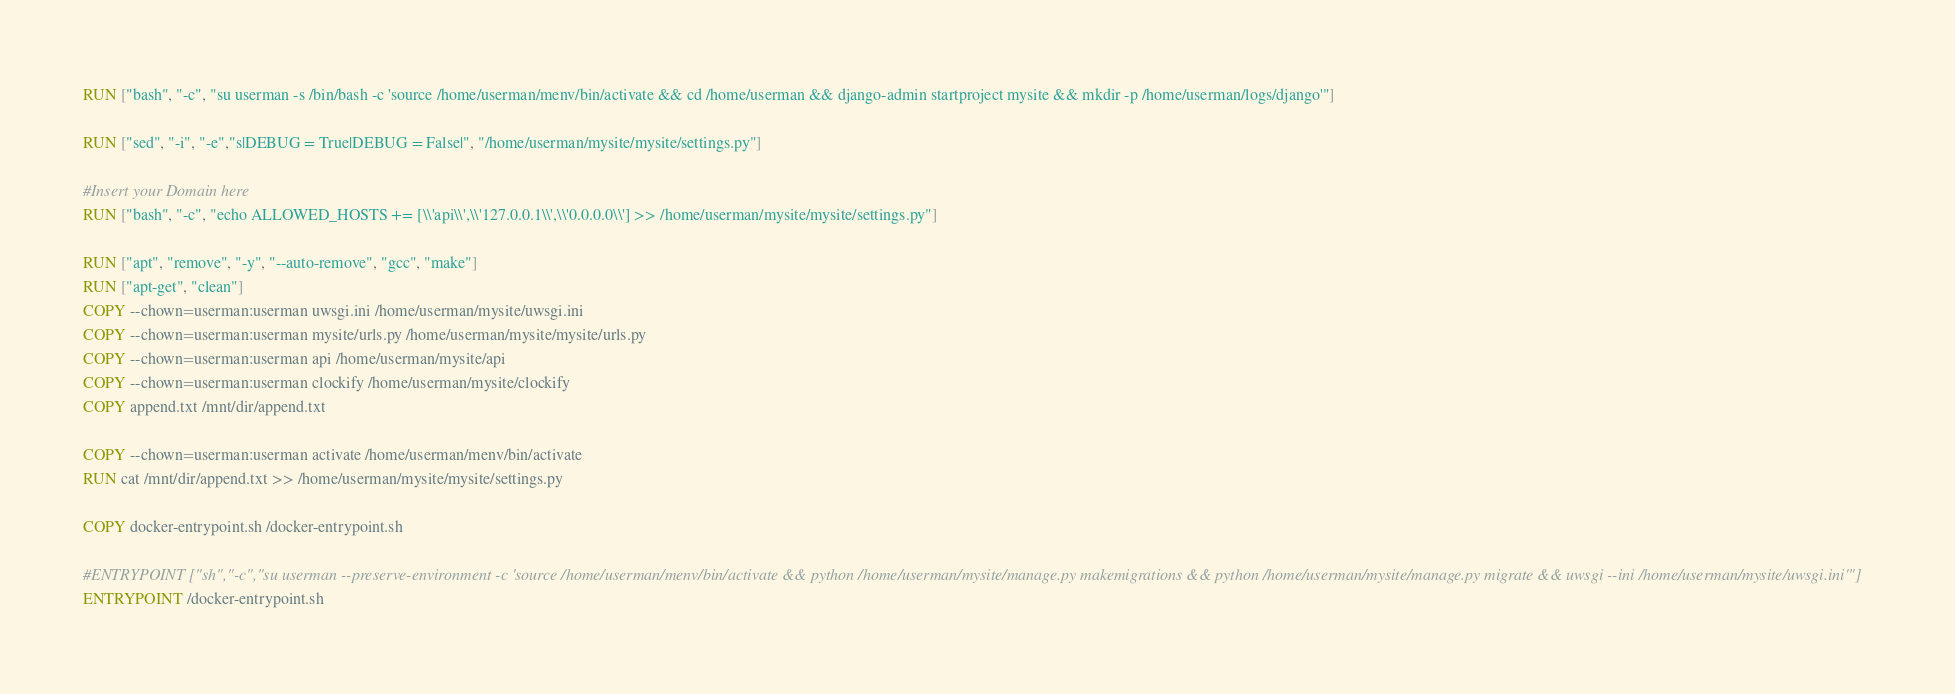Convert code to text. <code><loc_0><loc_0><loc_500><loc_500><_Dockerfile_>RUN ["bash", "-c", "su userman -s /bin/bash -c 'source /home/userman/menv/bin/activate && cd /home/userman && django-admin startproject mysite && mkdir -p /home/userman/logs/django'"]

RUN ["sed", "-i", "-e","s|DEBUG = True|DEBUG = False|", "/home/userman/mysite/mysite/settings.py"]

#Insert your Domain here
RUN ["bash", "-c", "echo ALLOWED_HOSTS += [\\'api\\',\\'127.0.0.1\\',\\'0.0.0.0\\'] >> /home/userman/mysite/mysite/settings.py"]

RUN ["apt", "remove", "-y", "--auto-remove", "gcc", "make"]
RUN ["apt-get", "clean"]
COPY --chown=userman:userman uwsgi.ini /home/userman/mysite/uwsgi.ini
COPY --chown=userman:userman mysite/urls.py /home/userman/mysite/mysite/urls.py
COPY --chown=userman:userman api /home/userman/mysite/api
COPY --chown=userman:userman clockify /home/userman/mysite/clockify
COPY append.txt /mnt/dir/append.txt

COPY --chown=userman:userman activate /home/userman/menv/bin/activate
RUN cat /mnt/dir/append.txt >> /home/userman/mysite/mysite/settings.py

COPY docker-entrypoint.sh /docker-entrypoint.sh

#ENTRYPOINT ["sh","-c","su userman --preserve-environment -c 'source /home/userman/menv/bin/activate && python /home/userman/mysite/manage.py makemigrations && python /home/userman/mysite/manage.py migrate && uwsgi --ini /home/userman/mysite/uwsgi.ini'"]
ENTRYPOINT /docker-entrypoint.sh
</code> 